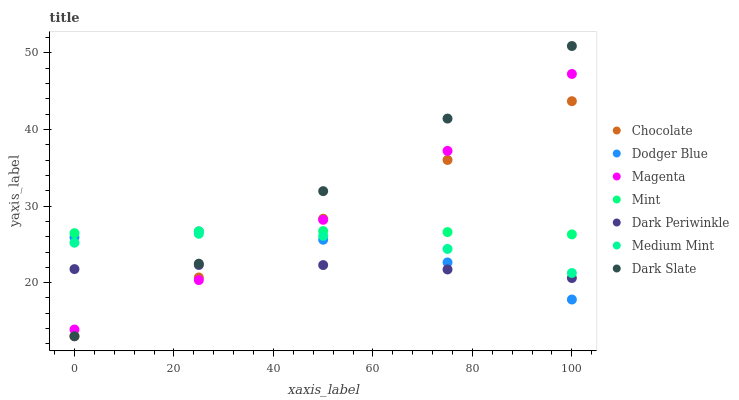Does Dark Periwinkle have the minimum area under the curve?
Answer yes or no. Yes. Does Dark Slate have the maximum area under the curve?
Answer yes or no. Yes. Does Chocolate have the minimum area under the curve?
Answer yes or no. No. Does Chocolate have the maximum area under the curve?
Answer yes or no. No. Is Dark Slate the smoothest?
Answer yes or no. Yes. Is Dodger Blue the roughest?
Answer yes or no. Yes. Is Chocolate the smoothest?
Answer yes or no. No. Is Chocolate the roughest?
Answer yes or no. No. Does Chocolate have the lowest value?
Answer yes or no. Yes. Does Dodger Blue have the lowest value?
Answer yes or no. No. Does Dark Slate have the highest value?
Answer yes or no. Yes. Does Chocolate have the highest value?
Answer yes or no. No. Is Medium Mint less than Mint?
Answer yes or no. Yes. Is Mint greater than Dark Periwinkle?
Answer yes or no. Yes. Does Chocolate intersect Magenta?
Answer yes or no. Yes. Is Chocolate less than Magenta?
Answer yes or no. No. Is Chocolate greater than Magenta?
Answer yes or no. No. Does Medium Mint intersect Mint?
Answer yes or no. No. 